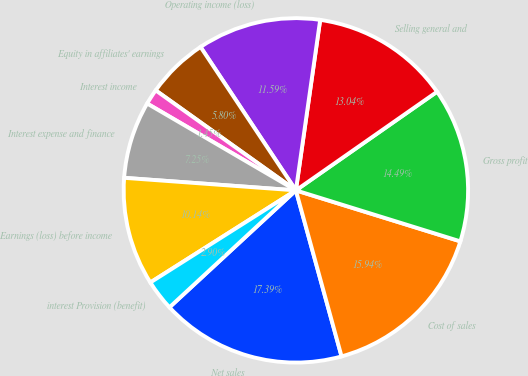Convert chart to OTSL. <chart><loc_0><loc_0><loc_500><loc_500><pie_chart><fcel>Net sales<fcel>Cost of sales<fcel>Gross profit<fcel>Selling general and<fcel>Operating income (loss)<fcel>Equity in affiliates' earnings<fcel>Interest income<fcel>Interest expense and finance<fcel>Earnings (loss) before income<fcel>interest Provision (benefit)<nl><fcel>17.39%<fcel>15.94%<fcel>14.49%<fcel>13.04%<fcel>11.59%<fcel>5.8%<fcel>1.45%<fcel>7.25%<fcel>10.14%<fcel>2.9%<nl></chart> 